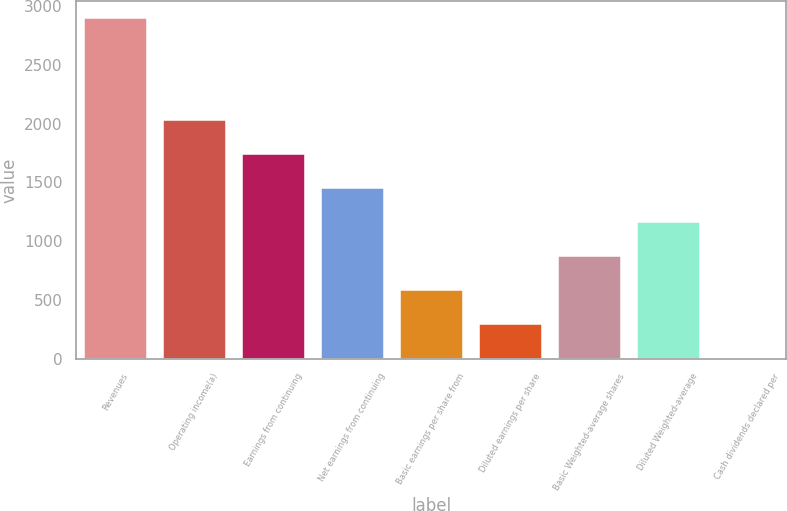Convert chart to OTSL. <chart><loc_0><loc_0><loc_500><loc_500><bar_chart><fcel>Revenues<fcel>Operating income(a)<fcel>Earnings from continuing<fcel>Net earnings from continuing<fcel>Basic earnings per share from<fcel>Diluted earnings per share<fcel>Basic Weighted-average shares<fcel>Diluted Weighted-average<fcel>Cash dividends declared per<nl><fcel>2897<fcel>2028.26<fcel>1738.68<fcel>1449.1<fcel>580.36<fcel>290.78<fcel>869.94<fcel>1159.52<fcel>1.2<nl></chart> 